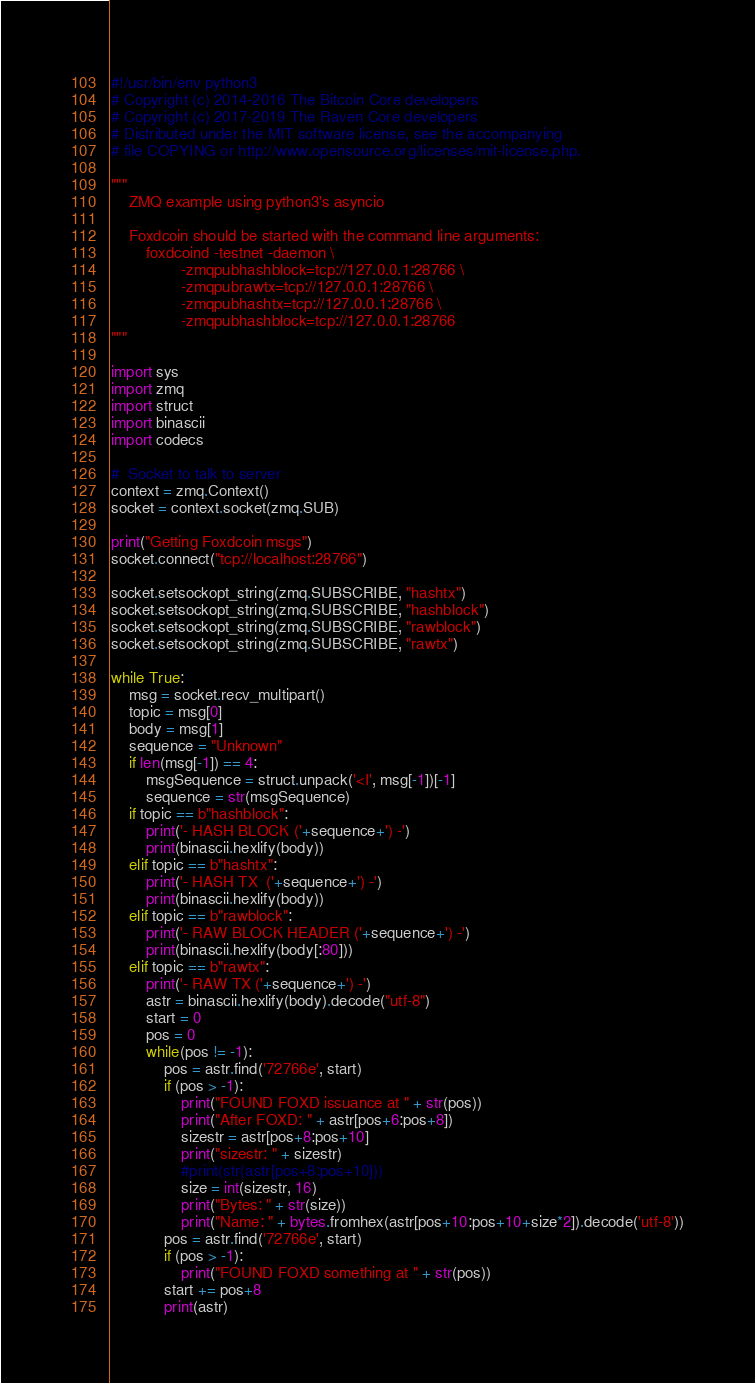<code> <loc_0><loc_0><loc_500><loc_500><_Python_>#!/usr/bin/env python3
# Copyright (c) 2014-2016 The Bitcoin Core developers
# Copyright (c) 2017-2019 The Raven Core developers
# Distributed under the MIT software license, see the accompanying
# file COPYING or http://www.opensource.org/licenses/mit-license.php.

"""
    ZMQ example using python3's asyncio

    Foxdcoin should be started with the command line arguments:
        foxdcoind -testnet -daemon \
                -zmqpubhashblock=tcp://127.0.0.1:28766 \
                -zmqpubrawtx=tcp://127.0.0.1:28766 \
                -zmqpubhashtx=tcp://127.0.0.1:28766 \
                -zmqpubhashblock=tcp://127.0.0.1:28766
"""

import sys
import zmq
import struct
import binascii
import codecs

#  Socket to talk to server
context = zmq.Context()
socket = context.socket(zmq.SUB)

print("Getting Foxdcoin msgs")
socket.connect("tcp://localhost:28766")

socket.setsockopt_string(zmq.SUBSCRIBE, "hashtx")
socket.setsockopt_string(zmq.SUBSCRIBE, "hashblock")
socket.setsockopt_string(zmq.SUBSCRIBE, "rawblock")
socket.setsockopt_string(zmq.SUBSCRIBE, "rawtx")

while True:
	msg = socket.recv_multipart()
	topic = msg[0]
	body = msg[1]
	sequence = "Unknown"
	if len(msg[-1]) == 4:
		msgSequence = struct.unpack('<I', msg[-1])[-1]
		sequence = str(msgSequence)
	if topic == b"hashblock":
		print('- HASH BLOCK ('+sequence+') -')
		print(binascii.hexlify(body))
	elif topic == b"hashtx":
		print('- HASH TX  ('+sequence+') -')
		print(binascii.hexlify(body))
	elif topic == b"rawblock":
		print('- RAW BLOCK HEADER ('+sequence+') -')
		print(binascii.hexlify(body[:80]))
	elif topic == b"rawtx":
		print('- RAW TX ('+sequence+') -')
		astr = binascii.hexlify(body).decode("utf-8")
		start = 0
		pos = 0
		while(pos != -1):
			pos = astr.find('72766e', start)
			if (pos > -1):
				print("FOUND FOXD issuance at " + str(pos))
				print("After FOXD: " + astr[pos+6:pos+8])
				sizestr = astr[pos+8:pos+10]
				print("sizestr: " + sizestr)
				#print(str(astr[pos+8:pos+10]))
				size = int(sizestr, 16)
				print("Bytes: " + str(size))
				print("Name: " + bytes.fromhex(astr[pos+10:pos+10+size*2]).decode('utf-8'))
			pos = astr.find('72766e', start)
			if (pos > -1):
				print("FOUND FOXD something at " + str(pos))
			start += pos+8
			print(astr)


</code> 